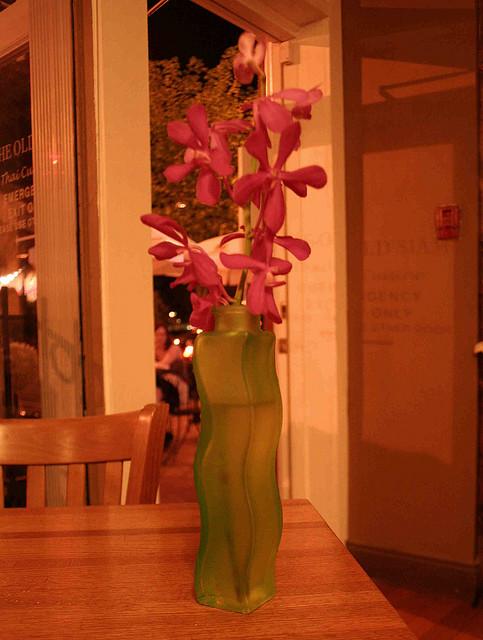How many stems are in the vase?
Give a very brief answer. 2. What is inside of the vase?
Concise answer only. Flowers. How many chairs are at the table?
Be succinct. 1. 